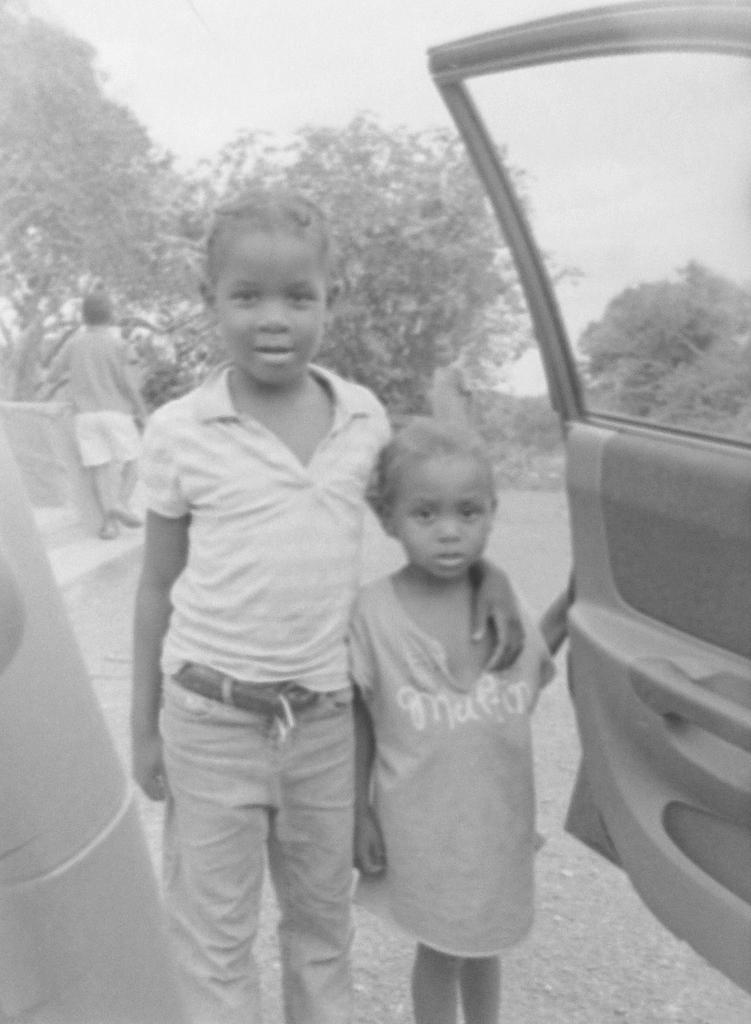What are the main subjects in the center of the image? There are persons standing in the center of the image. What can be seen on the right side of the image? There is a door on the right side of the image. What type of natural scenery is visible in the background of the image? There are trees in the background of the image. Can you describe the presence of another person in the image? There is a person standing in the background of the image. What type of flame can be seen on the person's head in the image? There is no flame present on anyone's head in the image. How does the person in the background maintain their balance in the image? The person in the background does not need to maintain balance, as they are standing still in the image. 